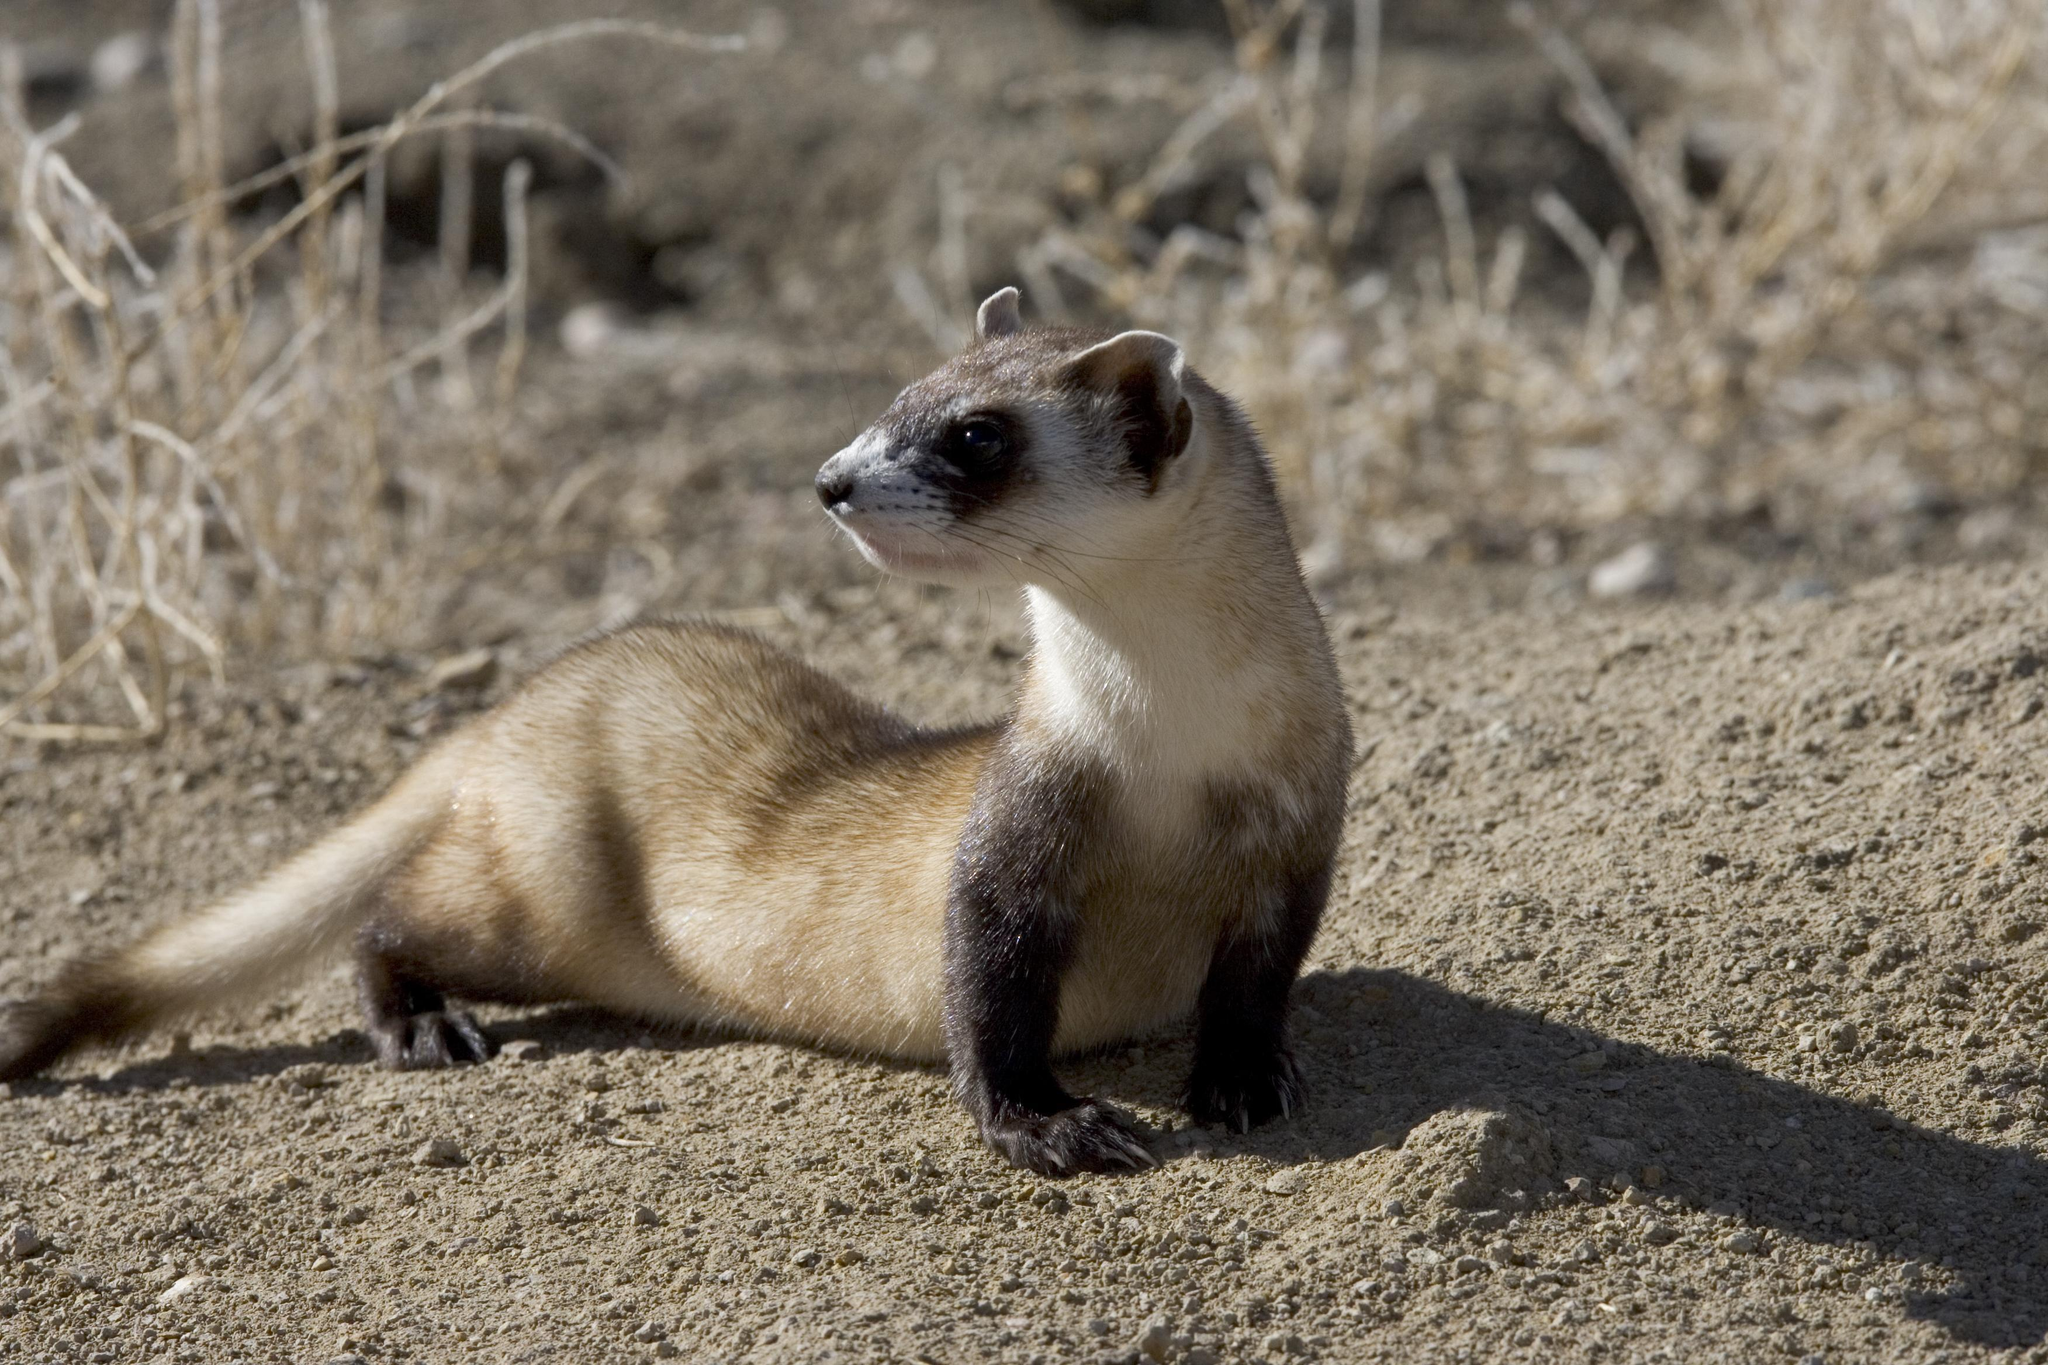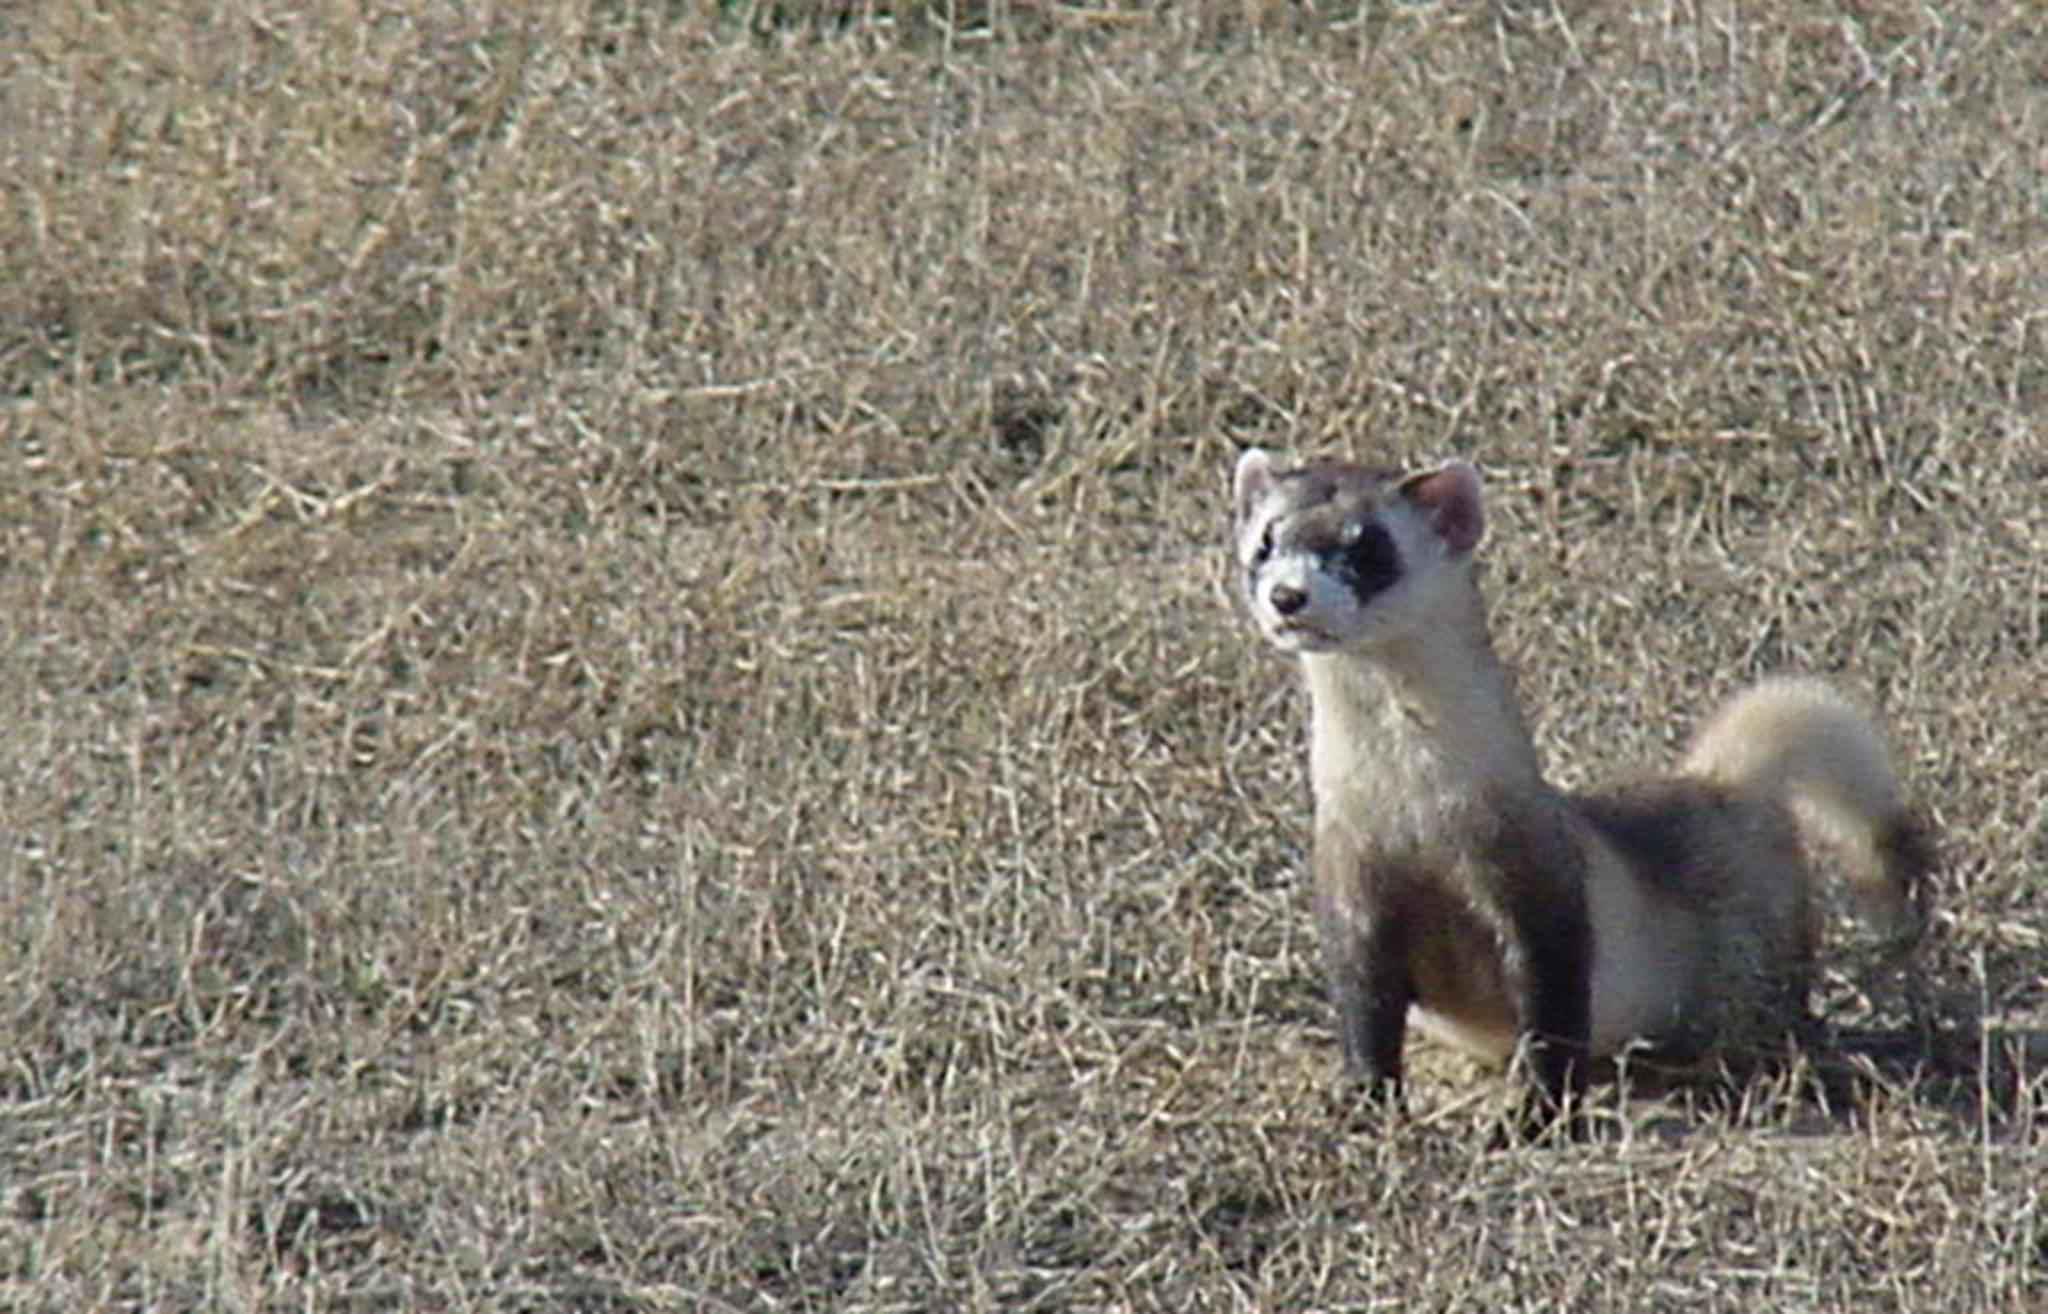The first image is the image on the left, the second image is the image on the right. For the images shown, is this caption "The animal in the image on the left is emerging from its burrow." true? Answer yes or no. No. 